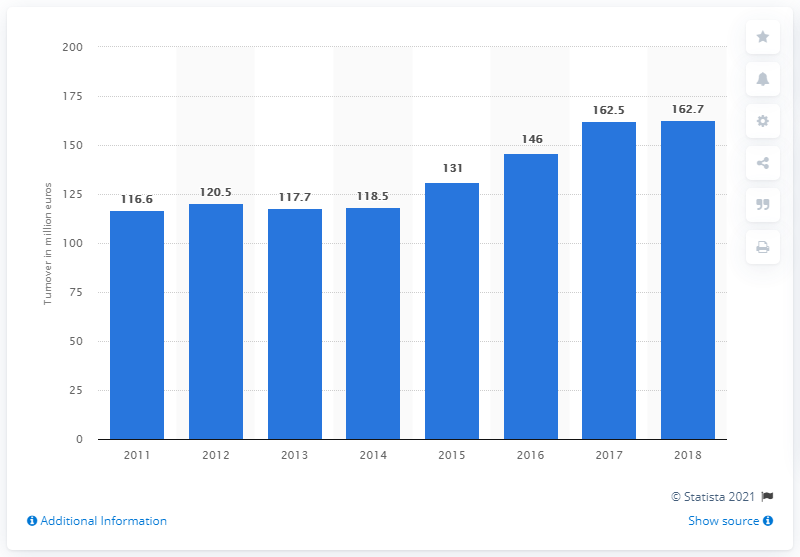Draw attention to some important aspects in this diagram. Pomellato Sp.A.'s turnover in 2018 was 162.7 million euros. 